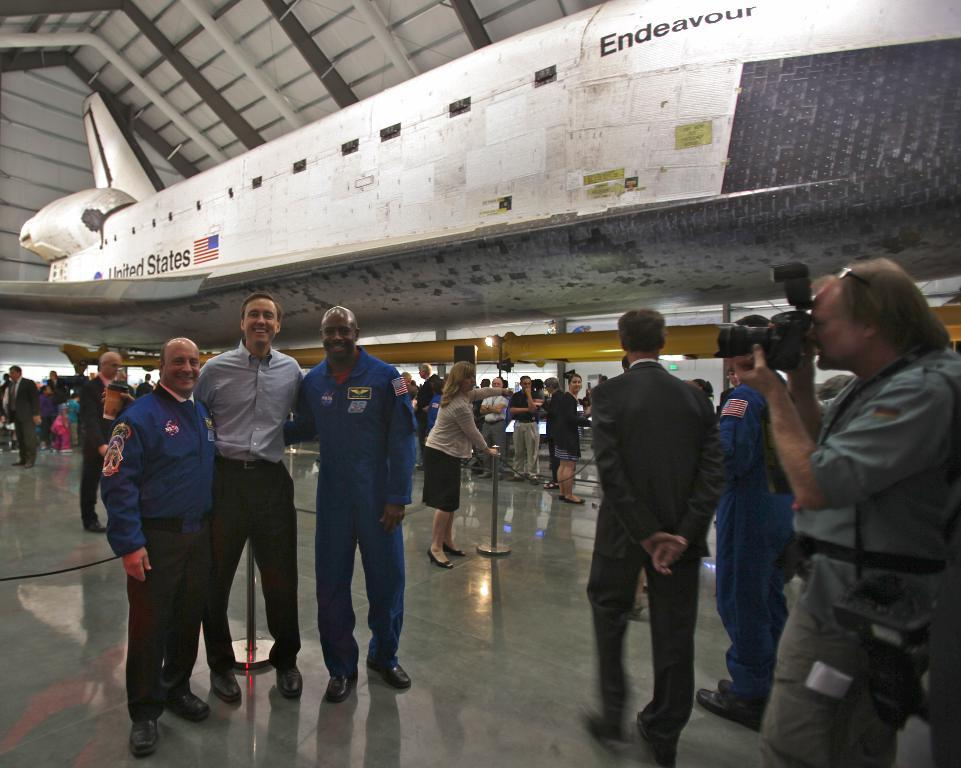<image>
Present a compact description of the photo's key features. People pose for photographs in front of the Space Shuttle Endeavour. 